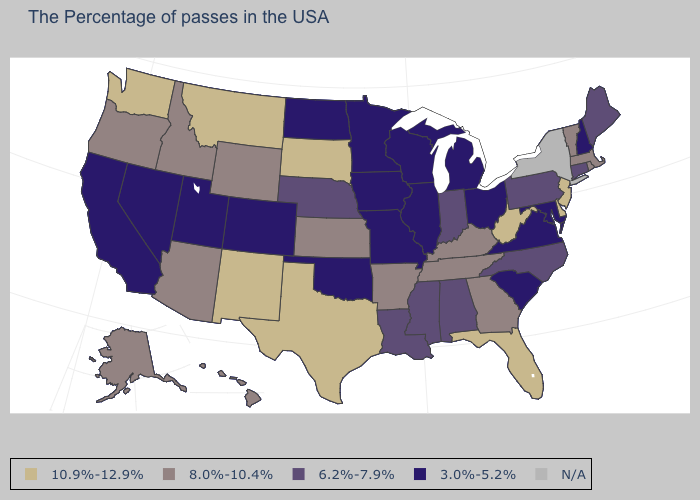What is the highest value in the Northeast ?
Keep it brief. 10.9%-12.9%. Does the map have missing data?
Answer briefly. Yes. How many symbols are there in the legend?
Concise answer only. 5. What is the value of Massachusetts?
Be succinct. 8.0%-10.4%. Name the states that have a value in the range 10.9%-12.9%?
Be succinct. New Jersey, Delaware, West Virginia, Florida, Texas, South Dakota, New Mexico, Montana, Washington. How many symbols are there in the legend?
Quick response, please. 5. What is the highest value in the South ?
Quick response, please. 10.9%-12.9%. What is the value of Louisiana?
Write a very short answer. 6.2%-7.9%. How many symbols are there in the legend?
Concise answer only. 5. What is the lowest value in states that border Pennsylvania?
Concise answer only. 3.0%-5.2%. What is the highest value in the USA?
Give a very brief answer. 10.9%-12.9%. What is the lowest value in states that border Wyoming?
Answer briefly. 3.0%-5.2%. What is the lowest value in the MidWest?
Write a very short answer. 3.0%-5.2%. Does the map have missing data?
Keep it brief. Yes. What is the value of California?
Quick response, please. 3.0%-5.2%. 